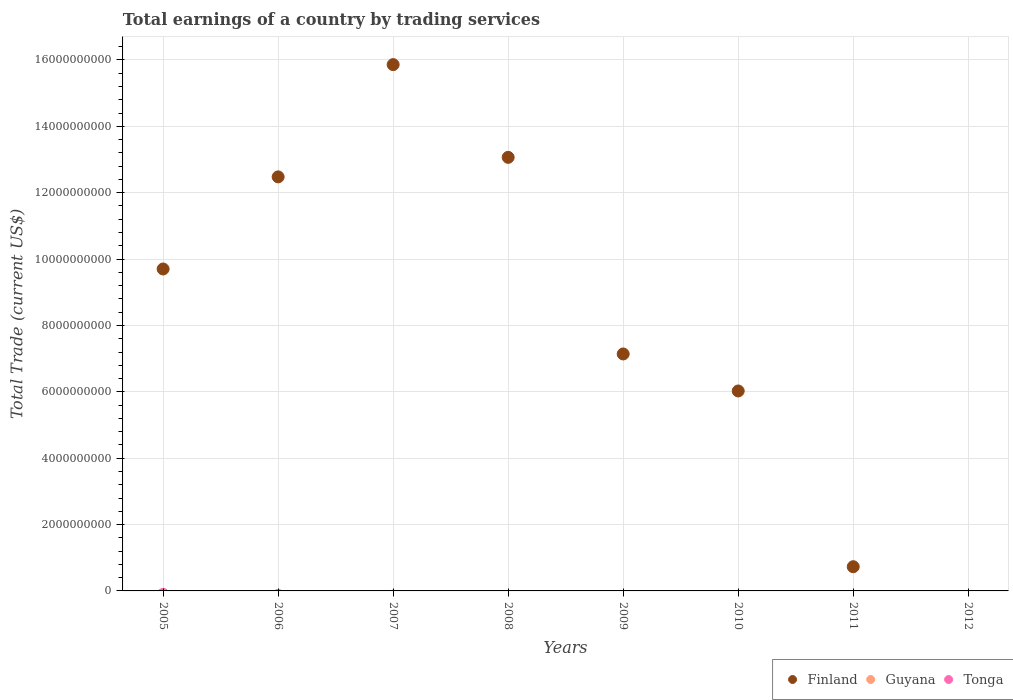How many different coloured dotlines are there?
Provide a succinct answer. 1. What is the total earnings in Guyana in 2012?
Provide a succinct answer. 0. Across all years, what is the maximum total earnings in Finland?
Offer a terse response. 1.59e+1. What is the total total earnings in Finland in the graph?
Make the answer very short. 6.50e+1. What is the difference between the total earnings in Finland in 2008 and that in 2009?
Give a very brief answer. 5.92e+09. What is the average total earnings in Guyana per year?
Offer a terse response. 0. What is the difference between the highest and the second highest total earnings in Finland?
Your answer should be very brief. 2.79e+09. What is the difference between the highest and the lowest total earnings in Finland?
Your answer should be compact. 1.59e+1. Is the sum of the total earnings in Finland in 2009 and 2010 greater than the maximum total earnings in Guyana across all years?
Provide a short and direct response. Yes. How many dotlines are there?
Your response must be concise. 1. Are the values on the major ticks of Y-axis written in scientific E-notation?
Offer a very short reply. No. Does the graph contain any zero values?
Make the answer very short. Yes. Does the graph contain grids?
Make the answer very short. Yes. Where does the legend appear in the graph?
Provide a short and direct response. Bottom right. How many legend labels are there?
Keep it short and to the point. 3. How are the legend labels stacked?
Make the answer very short. Horizontal. What is the title of the graph?
Give a very brief answer. Total earnings of a country by trading services. What is the label or title of the X-axis?
Give a very brief answer. Years. What is the label or title of the Y-axis?
Keep it short and to the point. Total Trade (current US$). What is the Total Trade (current US$) of Finland in 2005?
Provide a succinct answer. 9.70e+09. What is the Total Trade (current US$) of Guyana in 2005?
Give a very brief answer. 0. What is the Total Trade (current US$) of Tonga in 2005?
Your answer should be compact. 0. What is the Total Trade (current US$) in Finland in 2006?
Provide a short and direct response. 1.25e+1. What is the Total Trade (current US$) of Guyana in 2006?
Give a very brief answer. 0. What is the Total Trade (current US$) of Finland in 2007?
Keep it short and to the point. 1.59e+1. What is the Total Trade (current US$) of Finland in 2008?
Offer a terse response. 1.31e+1. What is the Total Trade (current US$) of Guyana in 2008?
Provide a succinct answer. 0. What is the Total Trade (current US$) of Finland in 2009?
Provide a succinct answer. 7.14e+09. What is the Total Trade (current US$) in Tonga in 2009?
Offer a very short reply. 0. What is the Total Trade (current US$) of Finland in 2010?
Your answer should be compact. 6.03e+09. What is the Total Trade (current US$) in Tonga in 2010?
Make the answer very short. 0. What is the Total Trade (current US$) of Finland in 2011?
Your response must be concise. 7.30e+08. What is the Total Trade (current US$) of Tonga in 2011?
Keep it short and to the point. 0. What is the Total Trade (current US$) of Finland in 2012?
Provide a short and direct response. 0. Across all years, what is the maximum Total Trade (current US$) in Finland?
Ensure brevity in your answer.  1.59e+1. Across all years, what is the minimum Total Trade (current US$) in Finland?
Provide a succinct answer. 0. What is the total Total Trade (current US$) of Finland in the graph?
Ensure brevity in your answer.  6.50e+1. What is the total Total Trade (current US$) in Guyana in the graph?
Your response must be concise. 0. What is the total Total Trade (current US$) in Tonga in the graph?
Ensure brevity in your answer.  0. What is the difference between the Total Trade (current US$) of Finland in 2005 and that in 2006?
Offer a very short reply. -2.78e+09. What is the difference between the Total Trade (current US$) in Finland in 2005 and that in 2007?
Make the answer very short. -6.16e+09. What is the difference between the Total Trade (current US$) in Finland in 2005 and that in 2008?
Provide a short and direct response. -3.36e+09. What is the difference between the Total Trade (current US$) in Finland in 2005 and that in 2009?
Ensure brevity in your answer.  2.56e+09. What is the difference between the Total Trade (current US$) of Finland in 2005 and that in 2010?
Keep it short and to the point. 3.68e+09. What is the difference between the Total Trade (current US$) in Finland in 2005 and that in 2011?
Provide a succinct answer. 8.97e+09. What is the difference between the Total Trade (current US$) in Finland in 2006 and that in 2007?
Make the answer very short. -3.38e+09. What is the difference between the Total Trade (current US$) of Finland in 2006 and that in 2008?
Your response must be concise. -5.88e+08. What is the difference between the Total Trade (current US$) in Finland in 2006 and that in 2009?
Keep it short and to the point. 5.34e+09. What is the difference between the Total Trade (current US$) in Finland in 2006 and that in 2010?
Provide a succinct answer. 6.45e+09. What is the difference between the Total Trade (current US$) in Finland in 2006 and that in 2011?
Provide a succinct answer. 1.17e+1. What is the difference between the Total Trade (current US$) in Finland in 2007 and that in 2008?
Ensure brevity in your answer.  2.79e+09. What is the difference between the Total Trade (current US$) in Finland in 2007 and that in 2009?
Your response must be concise. 8.72e+09. What is the difference between the Total Trade (current US$) of Finland in 2007 and that in 2010?
Your answer should be very brief. 9.83e+09. What is the difference between the Total Trade (current US$) in Finland in 2007 and that in 2011?
Keep it short and to the point. 1.51e+1. What is the difference between the Total Trade (current US$) in Finland in 2008 and that in 2009?
Ensure brevity in your answer.  5.92e+09. What is the difference between the Total Trade (current US$) in Finland in 2008 and that in 2010?
Offer a terse response. 7.04e+09. What is the difference between the Total Trade (current US$) in Finland in 2008 and that in 2011?
Your response must be concise. 1.23e+1. What is the difference between the Total Trade (current US$) of Finland in 2009 and that in 2010?
Provide a short and direct response. 1.12e+09. What is the difference between the Total Trade (current US$) in Finland in 2009 and that in 2011?
Provide a short and direct response. 6.41e+09. What is the difference between the Total Trade (current US$) in Finland in 2010 and that in 2011?
Ensure brevity in your answer.  5.30e+09. What is the average Total Trade (current US$) of Finland per year?
Offer a very short reply. 8.13e+09. What is the average Total Trade (current US$) of Guyana per year?
Your answer should be very brief. 0. What is the ratio of the Total Trade (current US$) of Finland in 2005 to that in 2006?
Make the answer very short. 0.78. What is the ratio of the Total Trade (current US$) in Finland in 2005 to that in 2007?
Your answer should be very brief. 0.61. What is the ratio of the Total Trade (current US$) in Finland in 2005 to that in 2008?
Keep it short and to the point. 0.74. What is the ratio of the Total Trade (current US$) of Finland in 2005 to that in 2009?
Your answer should be very brief. 1.36. What is the ratio of the Total Trade (current US$) in Finland in 2005 to that in 2010?
Your response must be concise. 1.61. What is the ratio of the Total Trade (current US$) in Finland in 2005 to that in 2011?
Provide a short and direct response. 13.3. What is the ratio of the Total Trade (current US$) in Finland in 2006 to that in 2007?
Make the answer very short. 0.79. What is the ratio of the Total Trade (current US$) of Finland in 2006 to that in 2008?
Provide a short and direct response. 0.95. What is the ratio of the Total Trade (current US$) of Finland in 2006 to that in 2009?
Offer a terse response. 1.75. What is the ratio of the Total Trade (current US$) of Finland in 2006 to that in 2010?
Give a very brief answer. 2.07. What is the ratio of the Total Trade (current US$) of Finland in 2006 to that in 2011?
Your response must be concise. 17.1. What is the ratio of the Total Trade (current US$) in Finland in 2007 to that in 2008?
Make the answer very short. 1.21. What is the ratio of the Total Trade (current US$) in Finland in 2007 to that in 2009?
Your answer should be compact. 2.22. What is the ratio of the Total Trade (current US$) of Finland in 2007 to that in 2010?
Your answer should be compact. 2.63. What is the ratio of the Total Trade (current US$) of Finland in 2007 to that in 2011?
Your response must be concise. 21.74. What is the ratio of the Total Trade (current US$) of Finland in 2008 to that in 2009?
Offer a terse response. 1.83. What is the ratio of the Total Trade (current US$) of Finland in 2008 to that in 2010?
Offer a very short reply. 2.17. What is the ratio of the Total Trade (current US$) of Finland in 2008 to that in 2011?
Your answer should be compact. 17.91. What is the ratio of the Total Trade (current US$) of Finland in 2009 to that in 2010?
Give a very brief answer. 1.19. What is the ratio of the Total Trade (current US$) in Finland in 2009 to that in 2011?
Your answer should be compact. 9.79. What is the ratio of the Total Trade (current US$) in Finland in 2010 to that in 2011?
Your answer should be very brief. 8.26. What is the difference between the highest and the second highest Total Trade (current US$) of Finland?
Provide a short and direct response. 2.79e+09. What is the difference between the highest and the lowest Total Trade (current US$) in Finland?
Provide a succinct answer. 1.59e+1. 